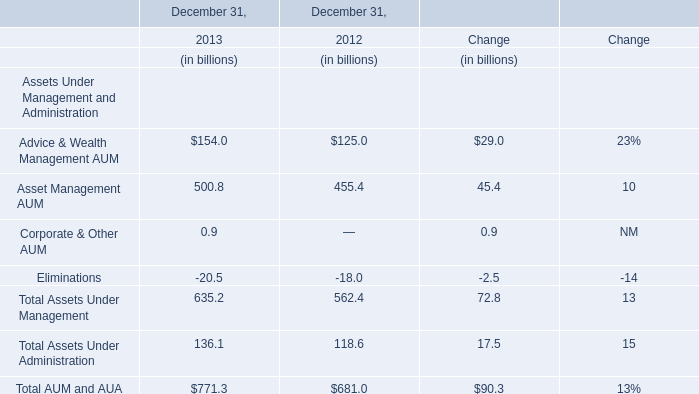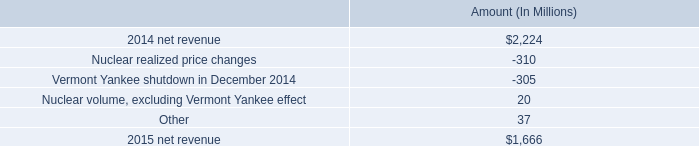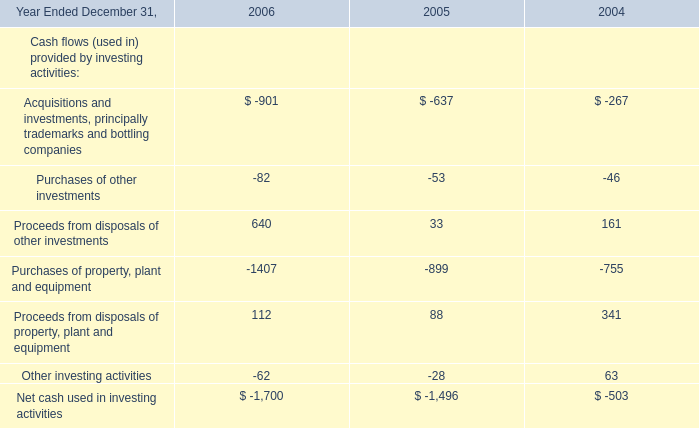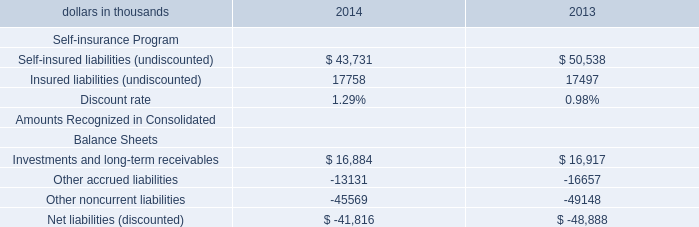What's the average of Net cash used in investing activities of 2006 is, and Other noncurrent liabilities Balance Sheets of 2013 ? 
Computations: ((1700.0 + 49148.0) / 2)
Answer: 25424.0. 